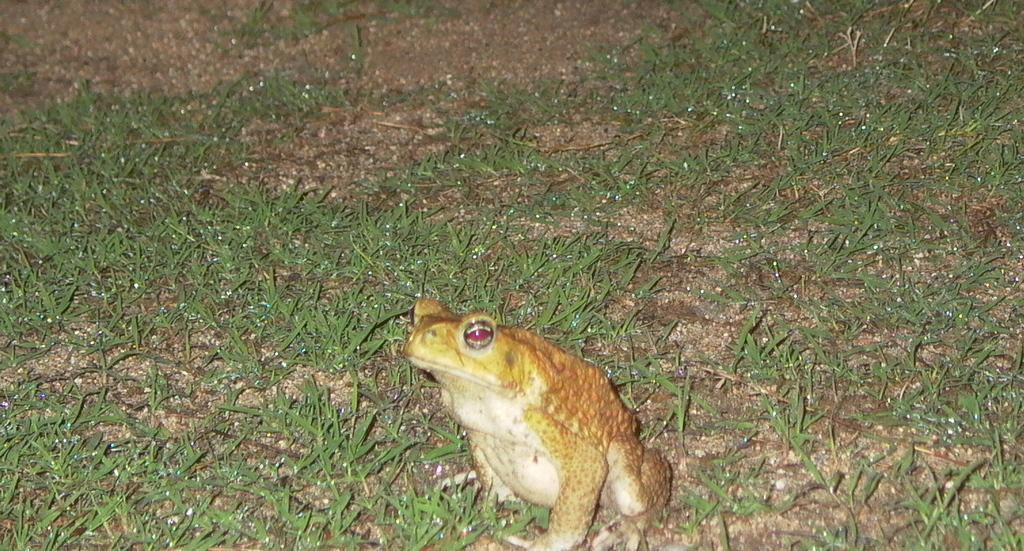How would you summarize this image in a sentence or two? This image consists of a frog. At the bottom, there is green grass on the ground. 